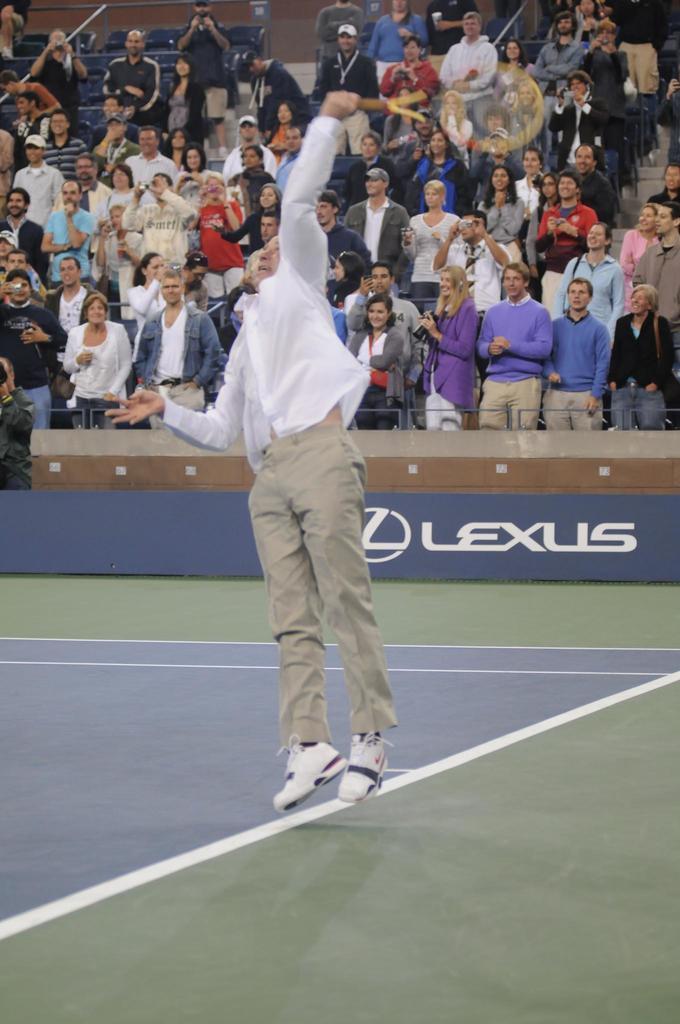Describe this image in one or two sentences. Front the man in white shirt is holding a racket and jumping. These are audience and they are standing. 